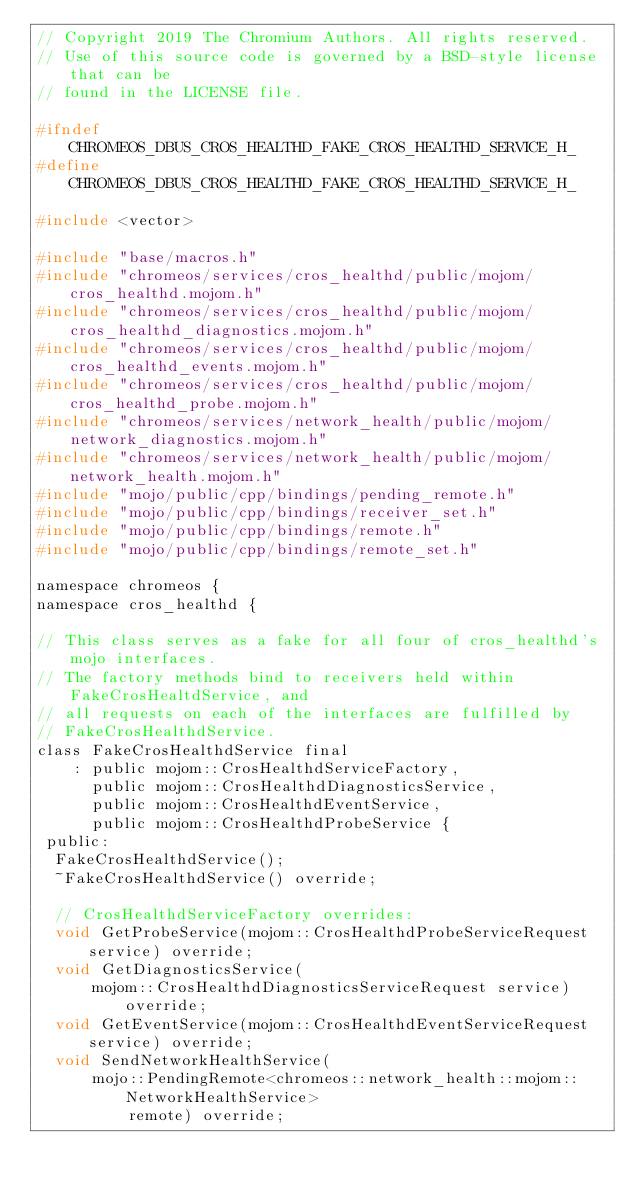Convert code to text. <code><loc_0><loc_0><loc_500><loc_500><_C_>// Copyright 2019 The Chromium Authors. All rights reserved.
// Use of this source code is governed by a BSD-style license that can be
// found in the LICENSE file.

#ifndef CHROMEOS_DBUS_CROS_HEALTHD_FAKE_CROS_HEALTHD_SERVICE_H_
#define CHROMEOS_DBUS_CROS_HEALTHD_FAKE_CROS_HEALTHD_SERVICE_H_

#include <vector>

#include "base/macros.h"
#include "chromeos/services/cros_healthd/public/mojom/cros_healthd.mojom.h"
#include "chromeos/services/cros_healthd/public/mojom/cros_healthd_diagnostics.mojom.h"
#include "chromeos/services/cros_healthd/public/mojom/cros_healthd_events.mojom.h"
#include "chromeos/services/cros_healthd/public/mojom/cros_healthd_probe.mojom.h"
#include "chromeos/services/network_health/public/mojom/network_diagnostics.mojom.h"
#include "chromeos/services/network_health/public/mojom/network_health.mojom.h"
#include "mojo/public/cpp/bindings/pending_remote.h"
#include "mojo/public/cpp/bindings/receiver_set.h"
#include "mojo/public/cpp/bindings/remote.h"
#include "mojo/public/cpp/bindings/remote_set.h"

namespace chromeos {
namespace cros_healthd {

// This class serves as a fake for all four of cros_healthd's mojo interfaces.
// The factory methods bind to receivers held within FakeCrosHealtdService, and
// all requests on each of the interfaces are fulfilled by
// FakeCrosHealthdService.
class FakeCrosHealthdService final
    : public mojom::CrosHealthdServiceFactory,
      public mojom::CrosHealthdDiagnosticsService,
      public mojom::CrosHealthdEventService,
      public mojom::CrosHealthdProbeService {
 public:
  FakeCrosHealthdService();
  ~FakeCrosHealthdService() override;

  // CrosHealthdServiceFactory overrides:
  void GetProbeService(mojom::CrosHealthdProbeServiceRequest service) override;
  void GetDiagnosticsService(
      mojom::CrosHealthdDiagnosticsServiceRequest service) override;
  void GetEventService(mojom::CrosHealthdEventServiceRequest service) override;
  void SendNetworkHealthService(
      mojo::PendingRemote<chromeos::network_health::mojom::NetworkHealthService>
          remote) override;</code> 